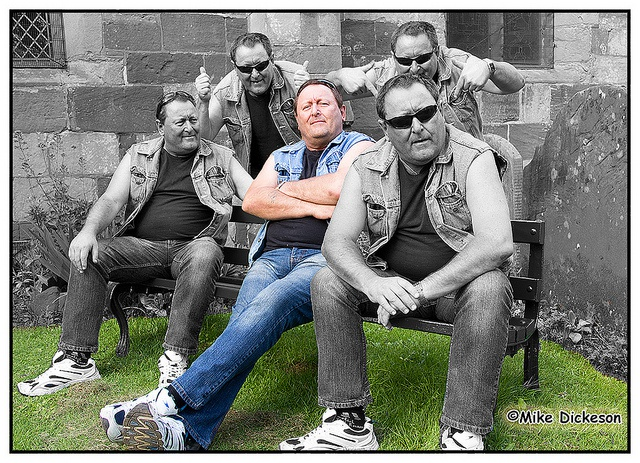Describe the objects in this image and their specific colors. I can see people in white, lightgray, gray, black, and darkgray tones, people in white, black, gray, lightgray, and darkgray tones, people in white, lightgray, black, navy, and darkgray tones, people in white, lightgray, darkgray, gray, and black tones, and people in white, black, gray, darkgray, and lightgray tones in this image. 